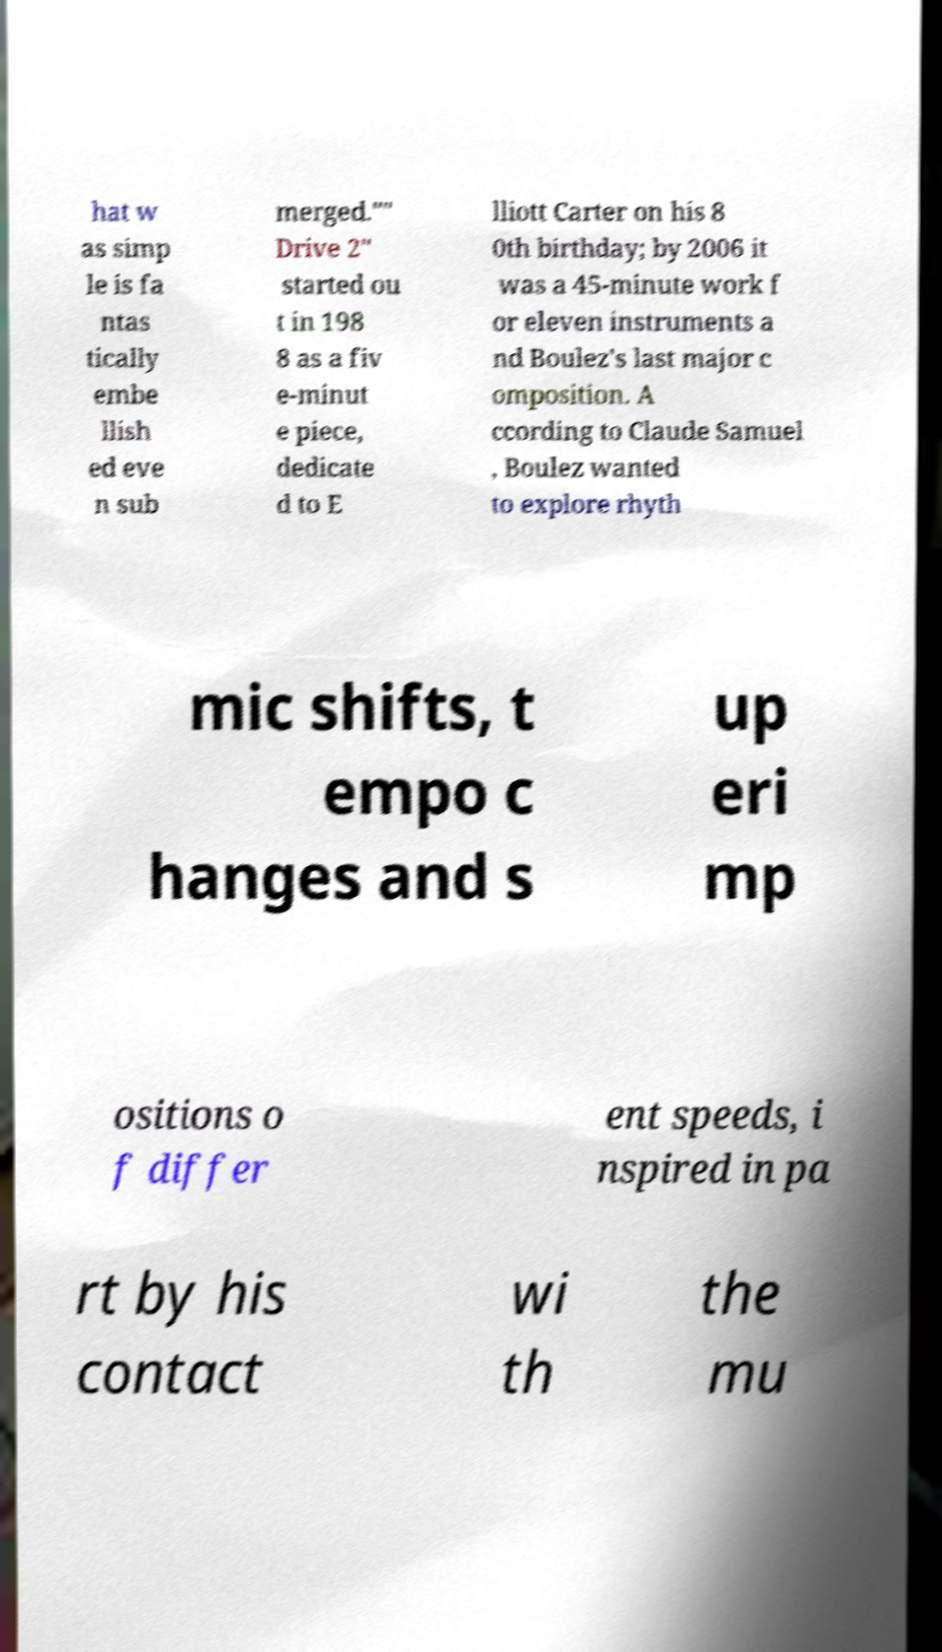Could you assist in decoding the text presented in this image and type it out clearly? hat w as simp le is fa ntas tically embe llish ed eve n sub merged."" Drive 2" started ou t in 198 8 as a fiv e-minut e piece, dedicate d to E lliott Carter on his 8 0th birthday; by 2006 it was a 45-minute work f or eleven instruments a nd Boulez's last major c omposition. A ccording to Claude Samuel , Boulez wanted to explore rhyth mic shifts, t empo c hanges and s up eri mp ositions o f differ ent speeds, i nspired in pa rt by his contact wi th the mu 